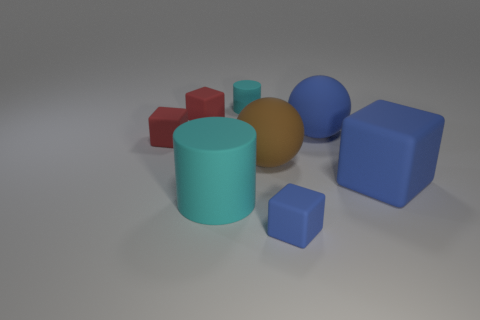There is a block in front of the big cylinder; does it have the same color as the big rubber ball to the right of the tiny blue matte block?
Provide a short and direct response. Yes. Is there a small cylinder that has the same color as the big cylinder?
Make the answer very short. Yes. There is a rubber ball that is the same size as the brown rubber thing; what is its color?
Provide a short and direct response. Blue. There is a rubber cylinder behind the large brown sphere; does it have the same color as the big cube?
Provide a short and direct response. No. Are there any other big cylinders made of the same material as the large cyan cylinder?
Provide a short and direct response. No. What shape is the big rubber thing that is the same color as the big rubber cube?
Offer a terse response. Sphere. Is the number of blue matte spheres left of the large cyan cylinder less than the number of green rubber blocks?
Offer a very short reply. No. Do the blue object behind the brown matte thing and the tiny cyan cylinder have the same size?
Give a very brief answer. No. What number of other large matte objects are the same shape as the brown thing?
Your response must be concise. 1. The blue ball that is the same material as the large brown thing is what size?
Offer a very short reply. Large. 